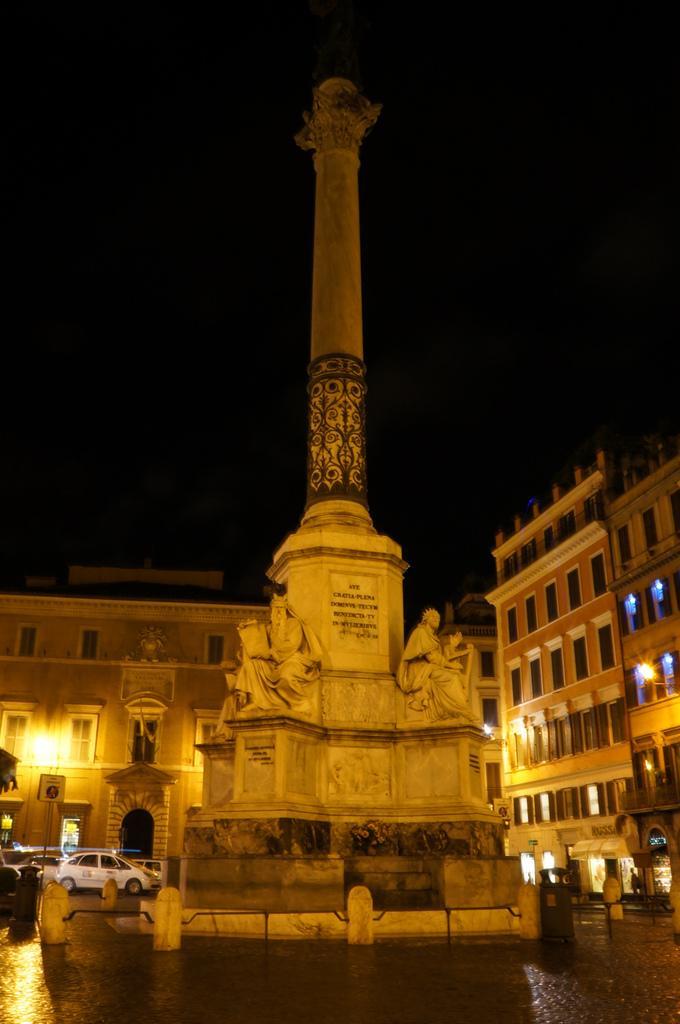Can you describe this image briefly? In this picture there is a tower in the center of the image and there are sculptures around it and there are buildings in the background area of the image and there are stalls and cars at the bottom side of the image, there is a boundary at the bottom side of the image. 